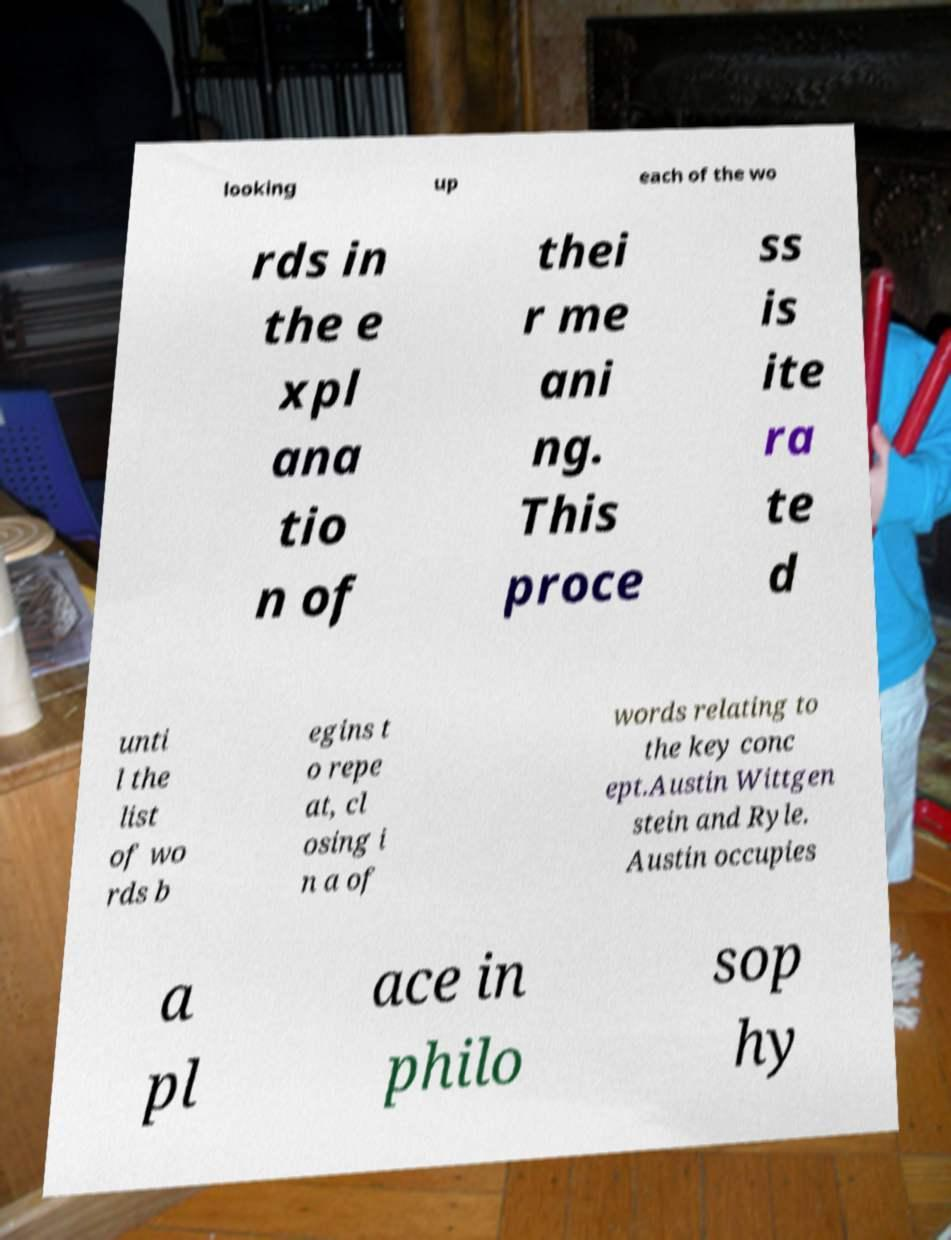For documentation purposes, I need the text within this image transcribed. Could you provide that? looking up each of the wo rds in the e xpl ana tio n of thei r me ani ng. This proce ss is ite ra te d unti l the list of wo rds b egins t o repe at, cl osing i n a of words relating to the key conc ept.Austin Wittgen stein and Ryle. Austin occupies a pl ace in philo sop hy 